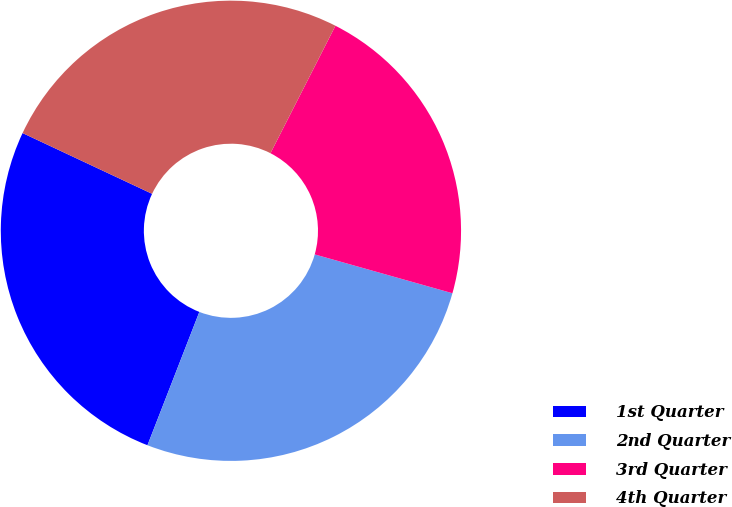<chart> <loc_0><loc_0><loc_500><loc_500><pie_chart><fcel>1st Quarter<fcel>2nd Quarter<fcel>3rd Quarter<fcel>4th Quarter<nl><fcel>26.07%<fcel>26.53%<fcel>21.87%<fcel>25.52%<nl></chart> 